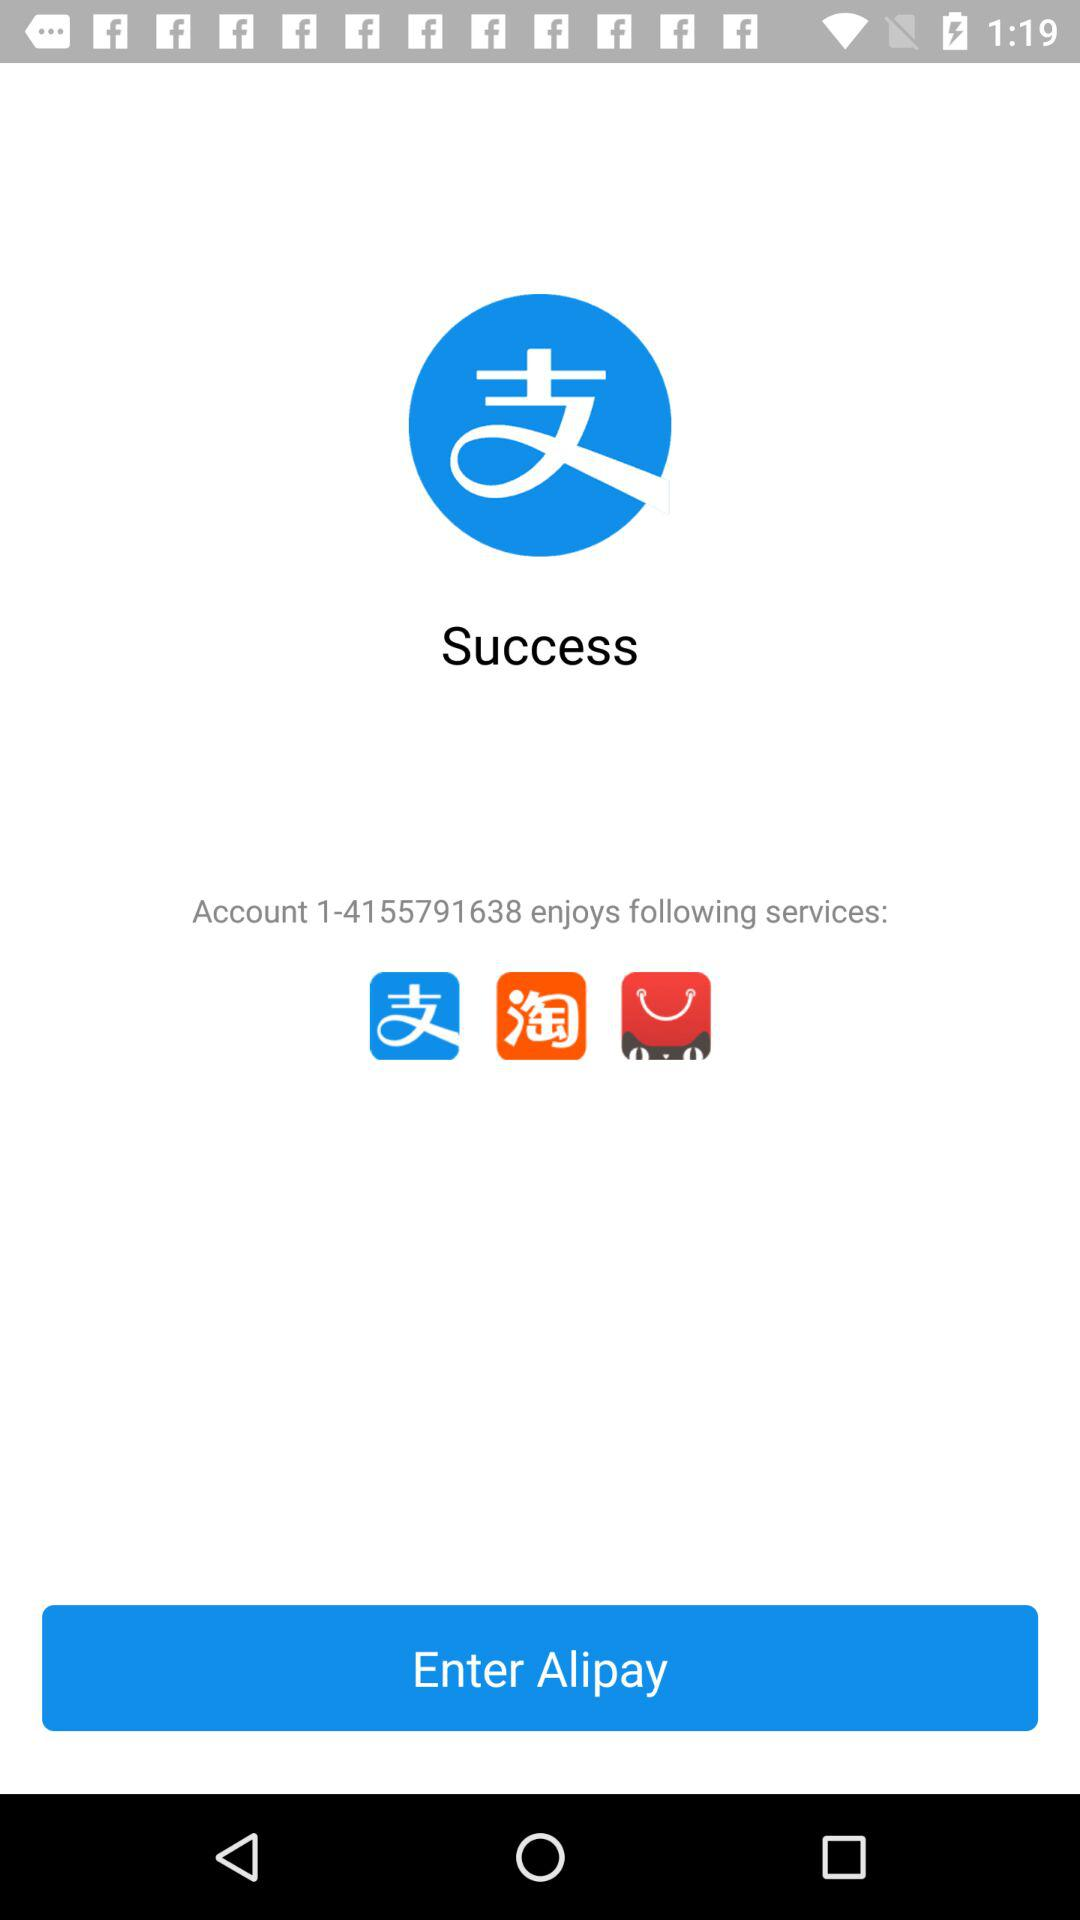How many services does the account enjoy?
Answer the question using a single word or phrase. 3 